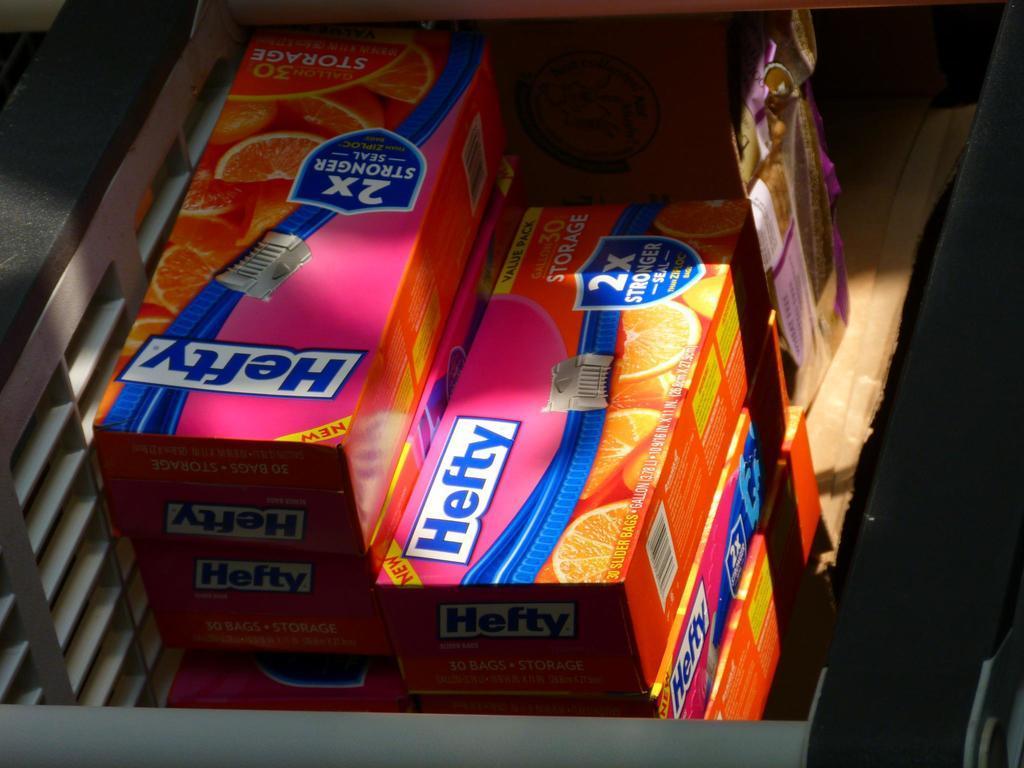Describe this image in one or two sentences. In this picture, we can see some boxes with some text, and images are placed on an object. 